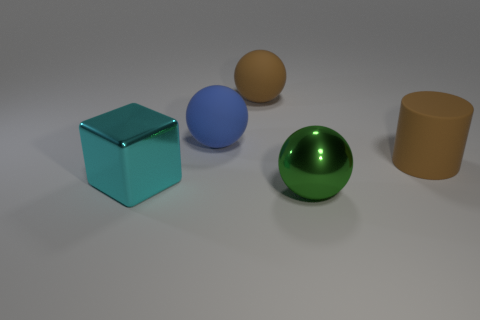Subtract all shiny spheres. How many spheres are left? 2 Add 3 blue rubber balls. How many objects exist? 8 Subtract all blocks. How many objects are left? 4 Subtract all cyan spheres. Subtract all red blocks. How many spheres are left? 3 Subtract all spheres. Subtract all large brown matte cylinders. How many objects are left? 1 Add 1 rubber spheres. How many rubber spheres are left? 3 Add 3 big brown rubber objects. How many big brown rubber objects exist? 5 Subtract 0 cyan balls. How many objects are left? 5 